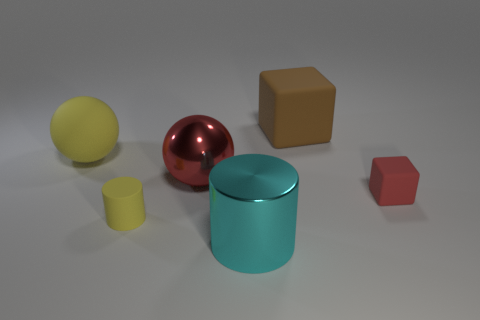Subtract all cyan cylinders. How many cylinders are left? 1 Add 3 red blocks. How many objects exist? 9 Subtract 1 cubes. How many cubes are left? 1 Add 4 small rubber blocks. How many small rubber blocks exist? 5 Subtract 1 yellow balls. How many objects are left? 5 Subtract all brown balls. Subtract all yellow cylinders. How many balls are left? 2 Subtract all green cylinders. How many yellow balls are left? 1 Subtract all large balls. Subtract all small red rubber cubes. How many objects are left? 3 Add 6 small blocks. How many small blocks are left? 7 